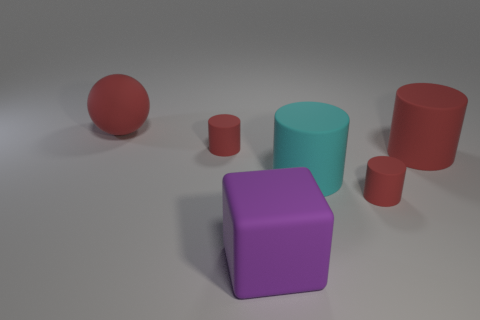What can you tell me about the lighting in the scene? The scene is lit from above with a soft light, casting subtle shadows directly underneath the objects, suggesting a single diffuse light source. Is there a specific mood or atmosphere that this lighting creates? The soft lighting creates a calm and neutral atmosphere. It's uniform and doesn't convey a particular emotion, making the scene seem very objective and straightforward. 